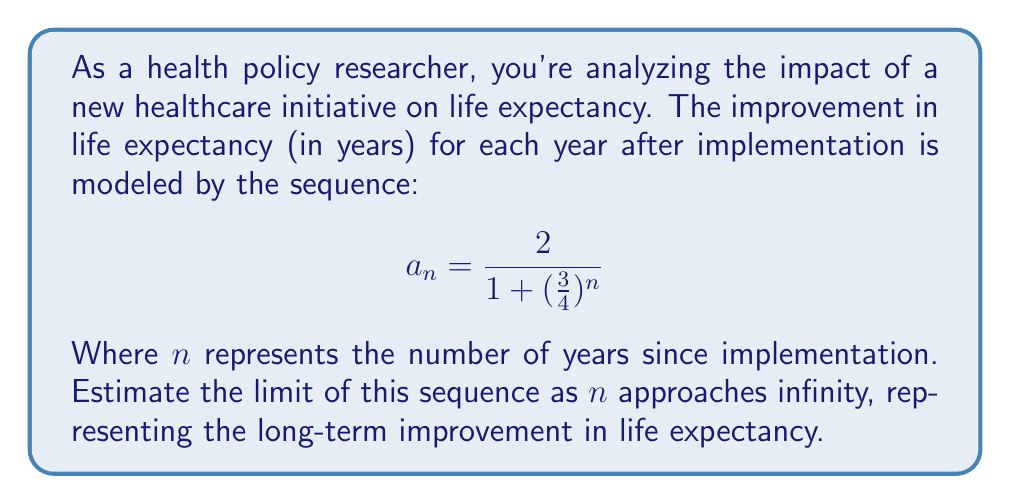Teach me how to tackle this problem. To estimate the limit of this sequence as $n$ approaches infinity, we need to analyze the behavior of the given formula:

$$a_n = \frac{2}{1 + (\frac{3}{4})^n}$$

1. First, let's consider what happens to $(\frac{3}{4})^n$ as $n$ approaches infinity:
   - Since $\frac{3}{4} < 1$, as $n$ increases, $(\frac{3}{4})^n$ will approach 0.

2. As $n \to \infty$, $(\frac{3}{4})^n \to 0$, so the denominator becomes:
   $$1 + (\frac{3}{4})^n \to 1 + 0 = 1$$

3. Therefore, as $n \to \infty$, the sequence approaches:
   $$\lim_{n \to \infty} a_n = \lim_{n \to \infty} \frac{2}{1 + (\frac{3}{4})^n} = \frac{2}{1} = 2$$

This means that in the long term, the healthcare initiative is expected to improve life expectancy by 2 years.
Answer: The limit of the sequence as $n$ approaches infinity is 2 years. 